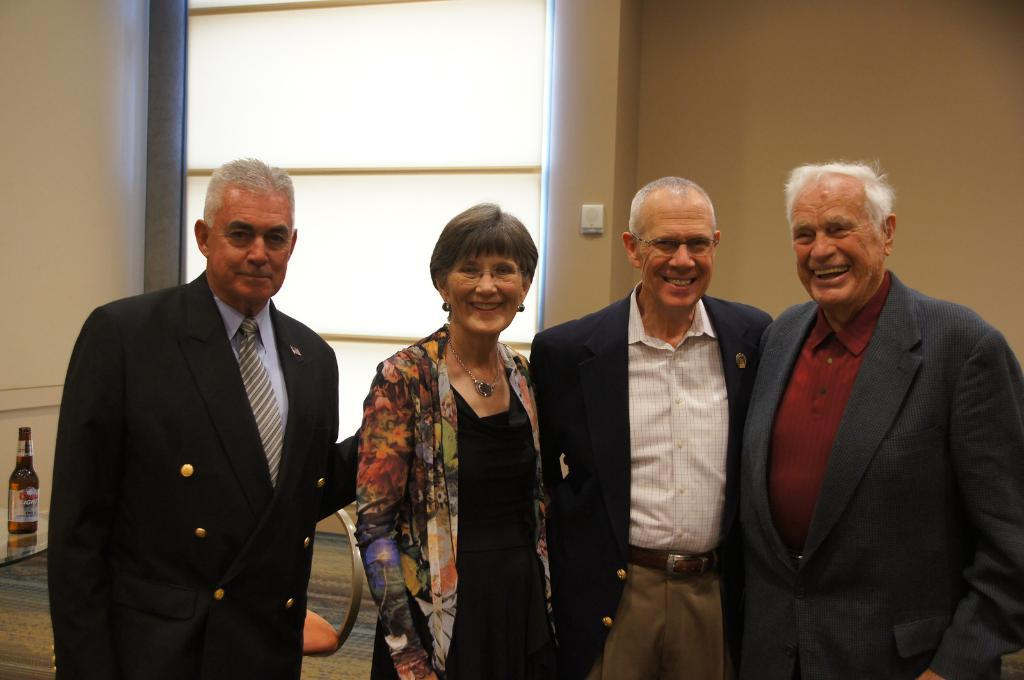What is happening in the image involving a group of people? There is a group of people in the image, and they are smiling. Can you describe the mood or emotion of the people in the image? The people in the image are smiling, which suggests a positive or happy mood. What can be seen in the background of the image? There is a wall in the background of the image. How much rain is falling during the rainstorm in the image? There is no rainstorm present in the image; it features a group of people smiling with a wall in the background. 